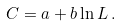Convert formula to latex. <formula><loc_0><loc_0><loc_500><loc_500>C = a + b \ln L \, .</formula> 